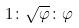Convert formula to latex. <formula><loc_0><loc_0><loc_500><loc_500>1 \colon \sqrt { \varphi } \colon \varphi</formula> 